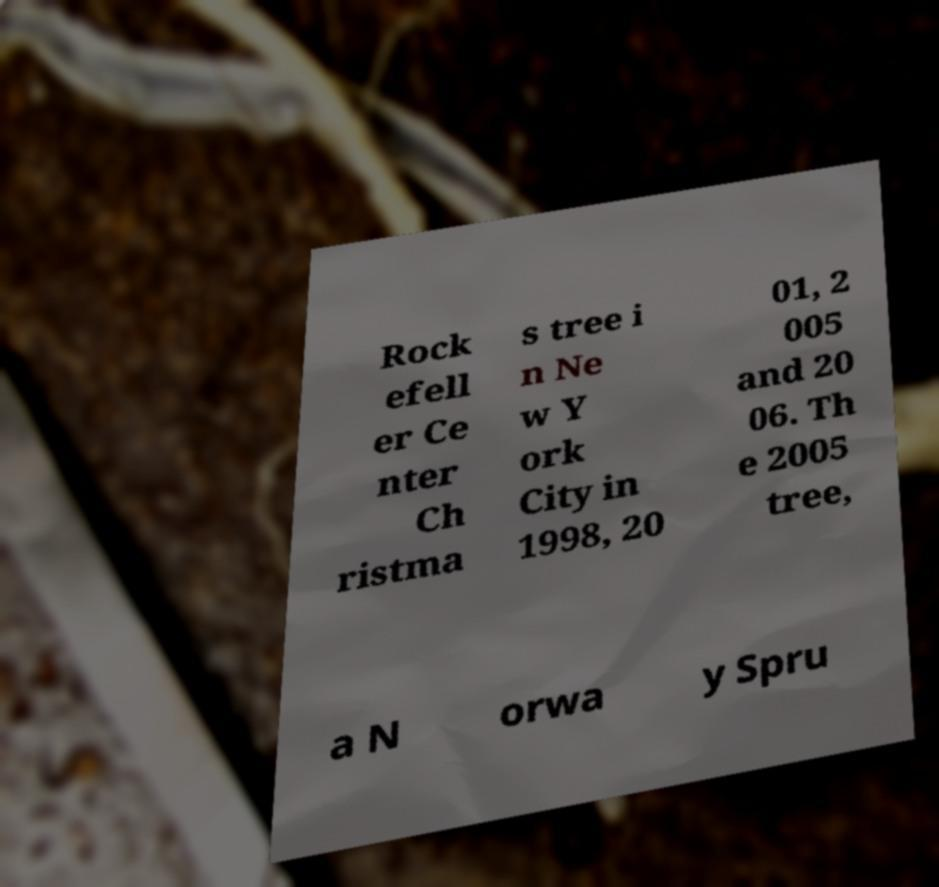For documentation purposes, I need the text within this image transcribed. Could you provide that? Rock efell er Ce nter Ch ristma s tree i n Ne w Y ork City in 1998, 20 01, 2 005 and 20 06. Th e 2005 tree, a N orwa y Spru 